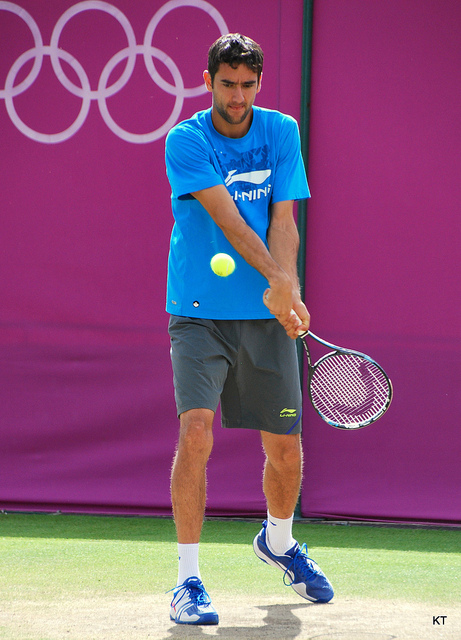<image>What letter is on the racket? I am not sure what letter is on the racket. It can be 'u', 'c', 'j' or 's'. What brand is his racquet? I am unsure about the brand of his racquet. It could be 'Wilson', 'Nike', 'Mizuno', or 'Adidas'. What letter is on the racket? I am not sure what letter is on the racket. It can be seen 'u', 'c', 'j' or 's'. What brand is his racquet? I am not sure what brand his racquet is. It can be from Wilson, Nike, Mizuno, or Adidas. 